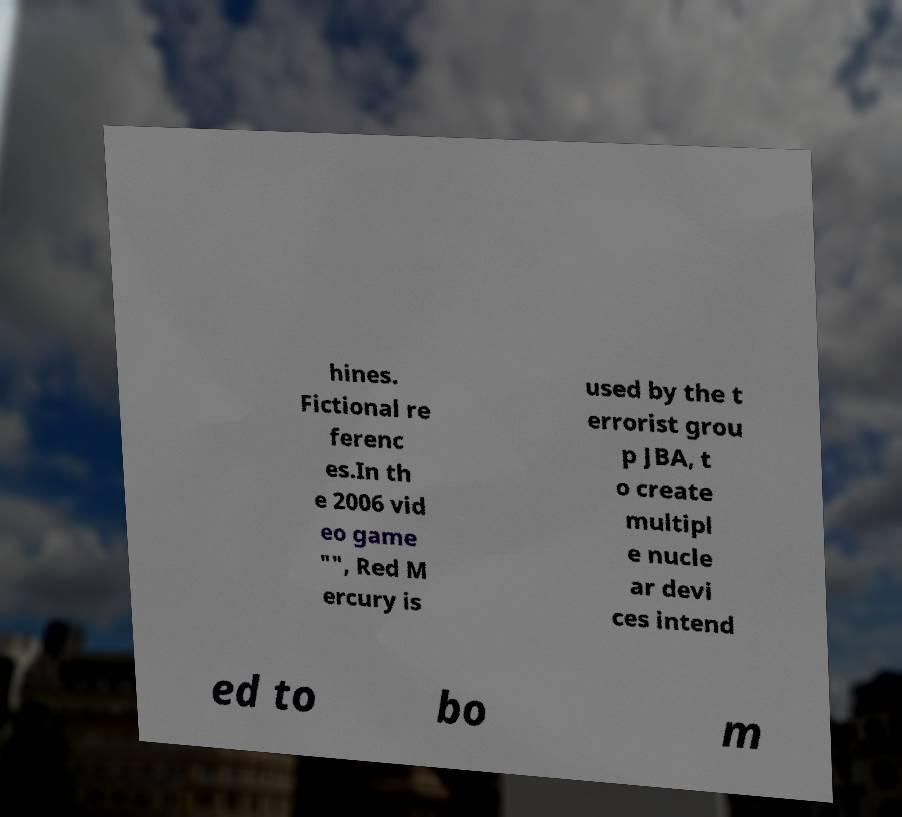Could you assist in decoding the text presented in this image and type it out clearly? hines. Fictional re ferenc es.In th e 2006 vid eo game "", Red M ercury is used by the t errorist grou p JBA, t o create multipl e nucle ar devi ces intend ed to bo m 